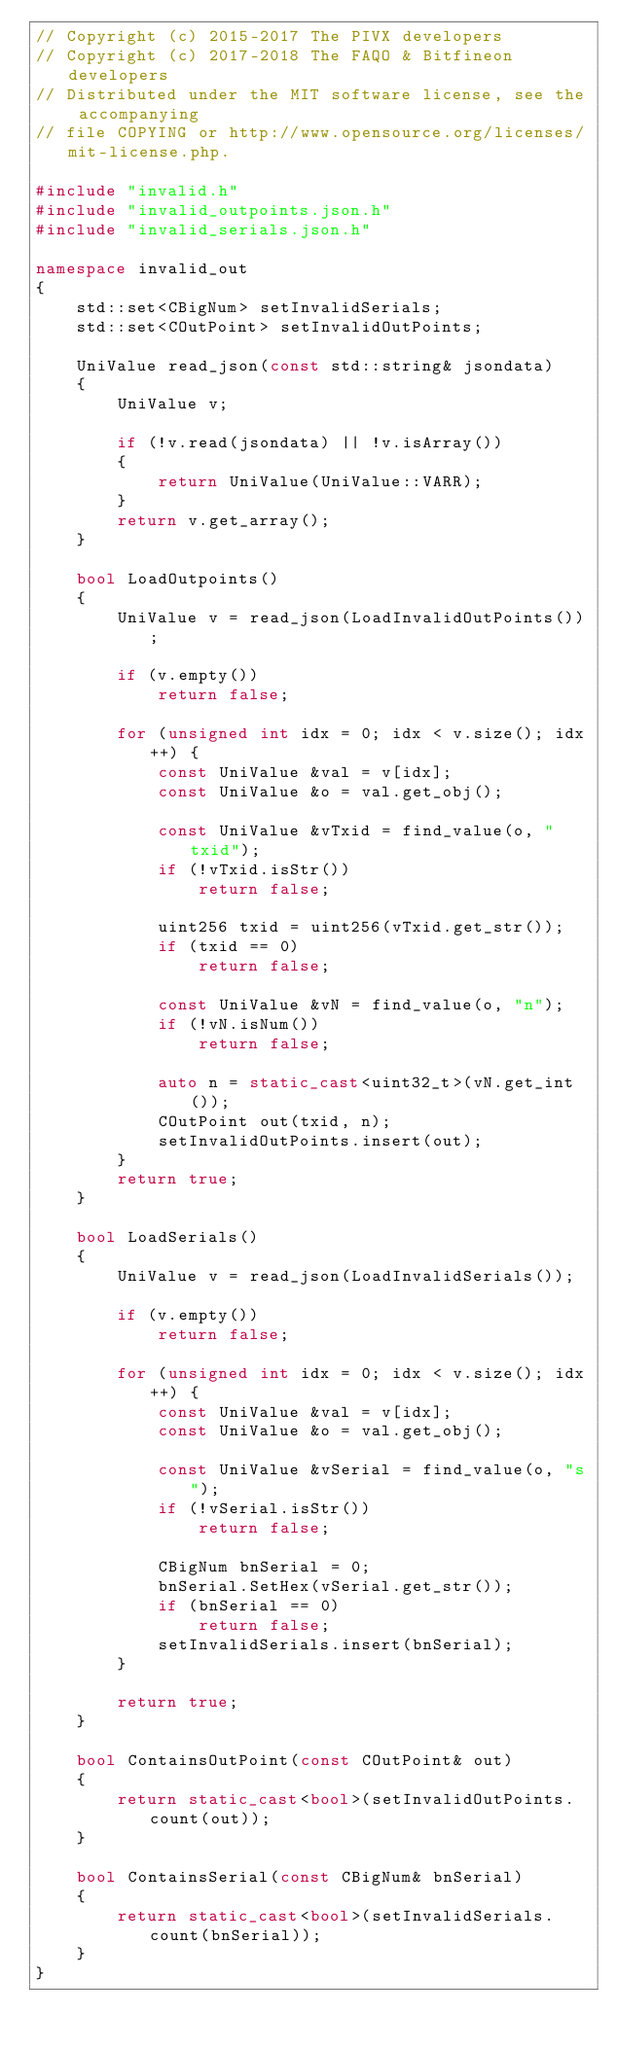Convert code to text. <code><loc_0><loc_0><loc_500><loc_500><_C++_>// Copyright (c) 2015-2017 The PIVX developers// Copyright (c) 2017-2018 The FAQO & Bitfineon developers
// Distributed under the MIT software license, see the accompanying
// file COPYING or http://www.opensource.org/licenses/mit-license.php.

#include "invalid.h"
#include "invalid_outpoints.json.h"
#include "invalid_serials.json.h"

namespace invalid_out
{
    std::set<CBigNum> setInvalidSerials;
    std::set<COutPoint> setInvalidOutPoints;

    UniValue read_json(const std::string& jsondata)
    {
        UniValue v;

        if (!v.read(jsondata) || !v.isArray())
        {
            return UniValue(UniValue::VARR);
        }
        return v.get_array();
    }

    bool LoadOutpoints()
    {
        UniValue v = read_json(LoadInvalidOutPoints());

        if (v.empty())
            return false;

        for (unsigned int idx = 0; idx < v.size(); idx++) {
            const UniValue &val = v[idx];
            const UniValue &o = val.get_obj();

            const UniValue &vTxid = find_value(o, "txid");
            if (!vTxid.isStr())
                return false;

            uint256 txid = uint256(vTxid.get_str());
            if (txid == 0)
                return false;

            const UniValue &vN = find_value(o, "n");
            if (!vN.isNum())
                return false;

            auto n = static_cast<uint32_t>(vN.get_int());
            COutPoint out(txid, n);
            setInvalidOutPoints.insert(out);
        }
        return true;
    }

    bool LoadSerials()
    {
        UniValue v = read_json(LoadInvalidSerials());

        if (v.empty())
            return false;

        for (unsigned int idx = 0; idx < v.size(); idx++) {
            const UniValue &val = v[idx];
            const UniValue &o = val.get_obj();

            const UniValue &vSerial = find_value(o, "s");
            if (!vSerial.isStr())
                return false;

            CBigNum bnSerial = 0;
            bnSerial.SetHex(vSerial.get_str());
            if (bnSerial == 0)
                return false;
            setInvalidSerials.insert(bnSerial);
        }

        return true;
    }

    bool ContainsOutPoint(const COutPoint& out)
    {
        return static_cast<bool>(setInvalidOutPoints.count(out));
    }

    bool ContainsSerial(const CBigNum& bnSerial)
    {
        return static_cast<bool>(setInvalidSerials.count(bnSerial));
    }
}

</code> 